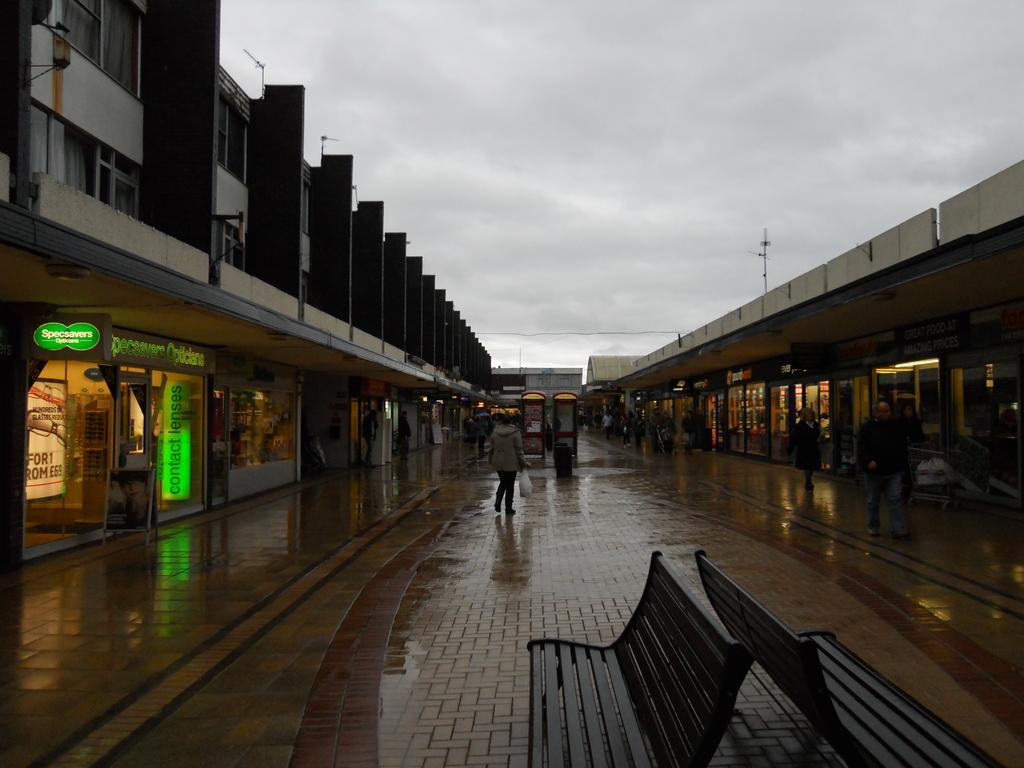How many people are in the image? There are persons in the image. What type of seating is present in the image? There are benches in the image. What type of pathway is visible in the image? There is a road in the image. What type of signage is present in the image? There are boards in the image. What type of structures are visible in the image? There are buildings in the image. What type of illumination is present in the image? There are lights in the image. What type of vertical structures are present in the image? There are poles in the image. What is visible in the background of the image? The sky is visible in the background of the image. Can you tell me how many maids are present in the image? There is no mention of maids in the image; the focus is on persons, benches, a road, boards, buildings, lights, poles, and the sky. What type of insect is crawling on the base of the pole in the image? There is no insect or base of a pole present in the image. 